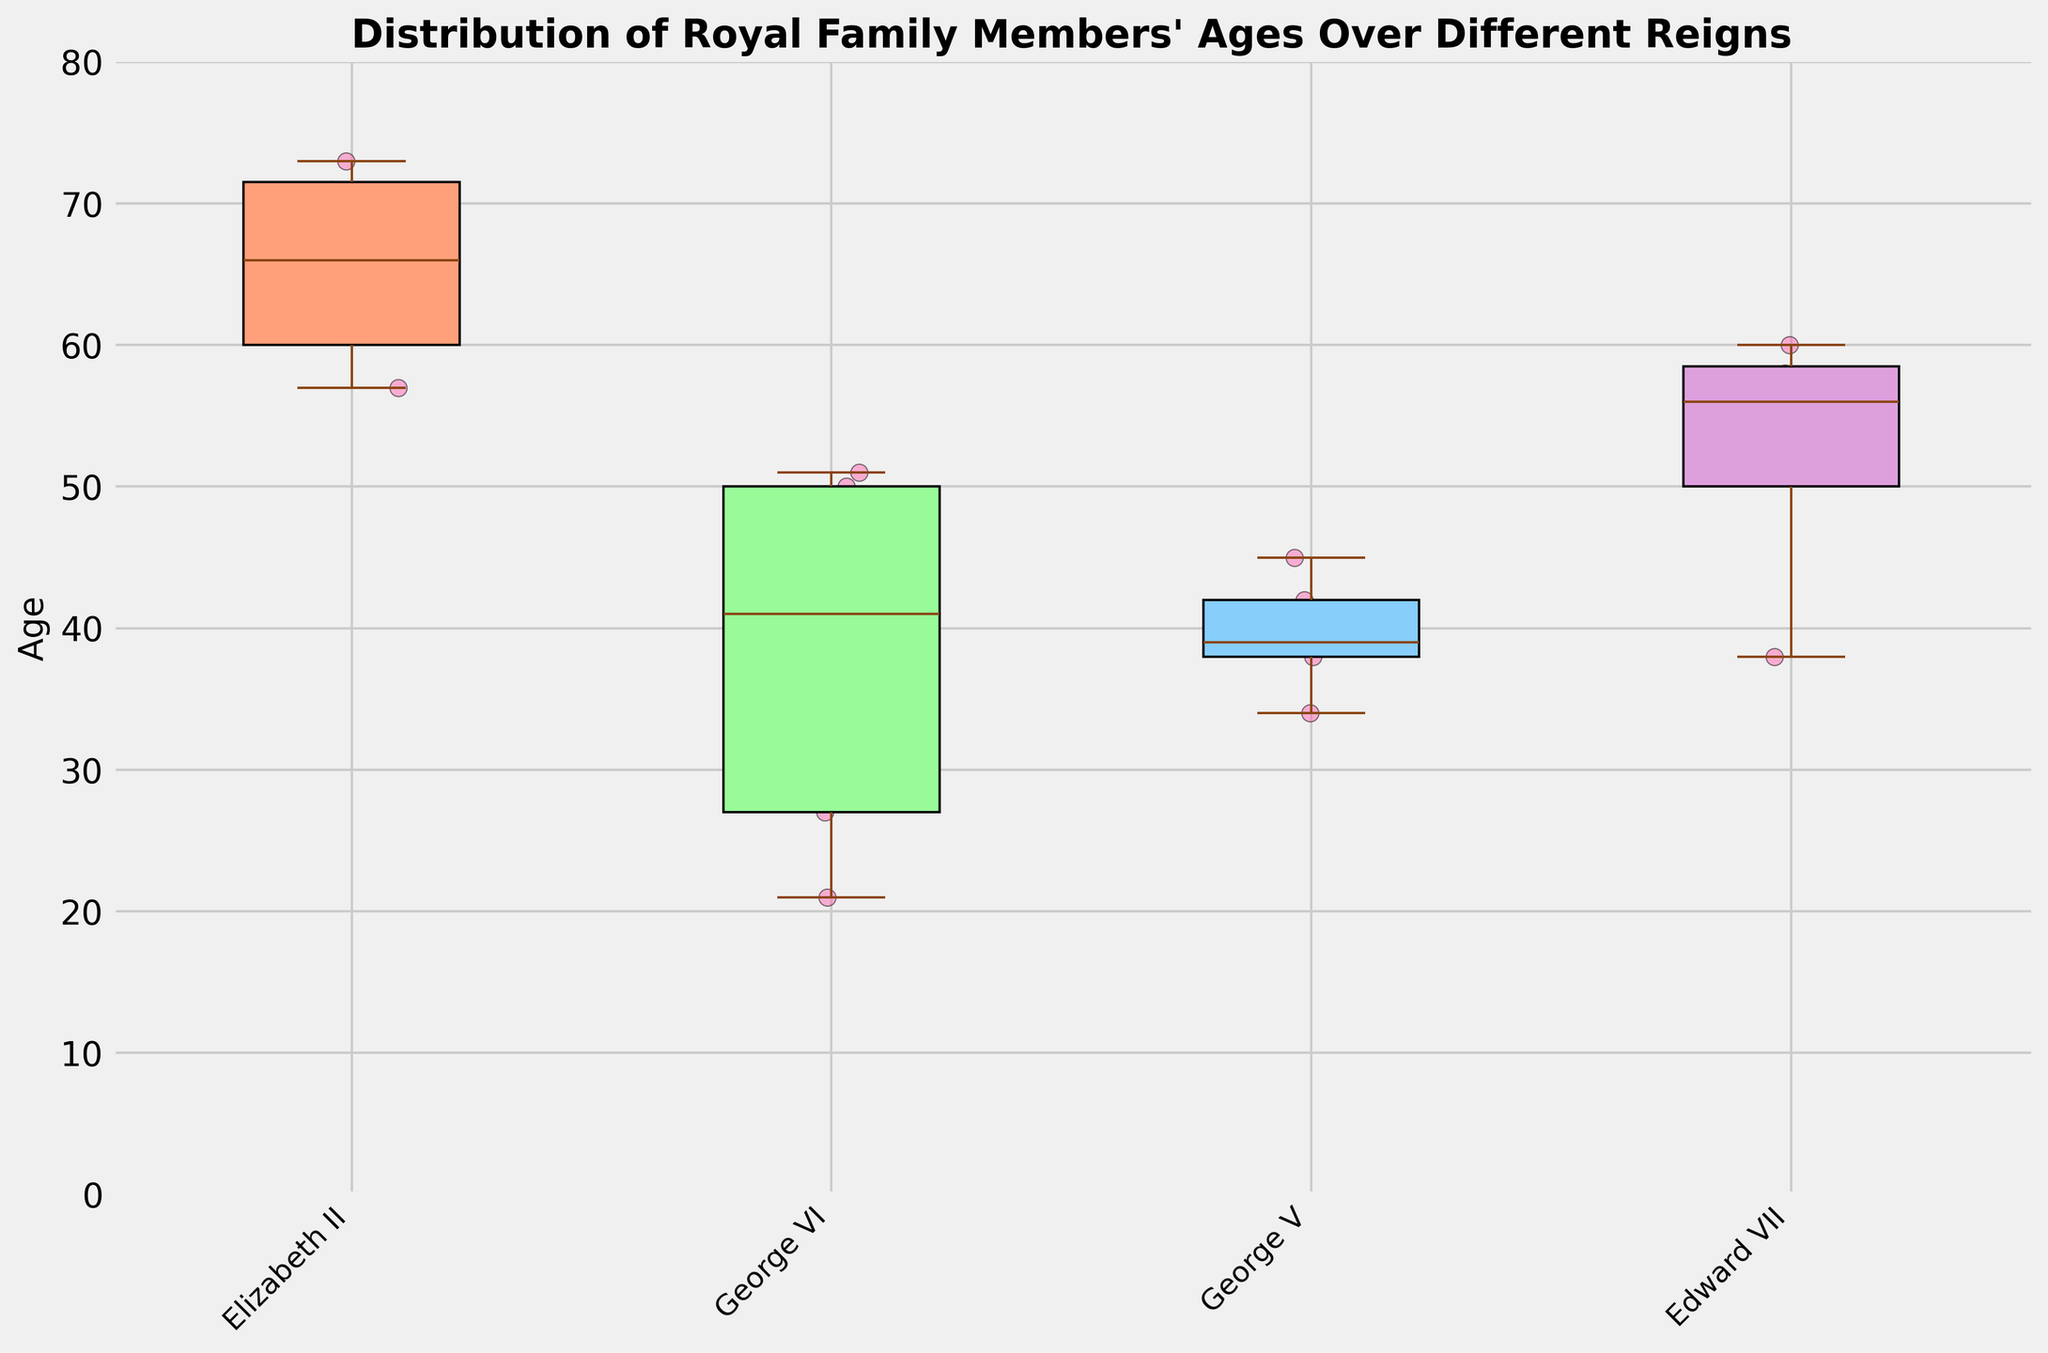What is the title of the figure? The title of the figure is displayed at the top and reads "Distribution of Royal Family Members' Ages Over Different Reigns."
Answer: Distribution of Royal Family Members' Ages Over Different Reigns Which reign has the widest age range? The widest age range is indicated by the length of the boxplot's whiskers. The reign with the longest whiskers represents the widest age range, which appears to be "Edward VII."
Answer: Edward VII How many royal family members are depicted under the reign of George V? Count the individual data points (dots) that fall under the "George V" category on the x-axis.
Answer: 5 What's the median age of members during Elizabeth II's reign? The median age is marked by the line inside the box for the "Elizabeth II" category.
Answer: 61 Which reign has the youngest member, and what is their age? The youngest member's age is identified as the lowest point on the y-axis range for each reign. The lowest point is under "George VI" with an age of 21.
Answer: George VI, 21 Compare the median ages of George V and George VI. Which reign has the higher median age? The median age is represented by the line inside each box. Compare the lines for "George V" and "George VI" categories; "George V" has a higher median age.
Answer: George V What is the interquartile range (IQR) for George VI's reign? The IQR is the length of the box representing the middle 50% of the data. The lower and upper edges of the box are the first (Q1) and third (Q3) quartiles, respectively. Estimate these values from the plot and subtract Q1 from Q3.
Answer: ~30 (estimated from visual interpretation) Which reign has the smallest number of "whiskers" longer than the box? Visually inspect the whiskers for each reign and determine which one has the shortest whiskers in comparison to its box length.
Answer: Elizabeth II How does the variation in ages during Edward VII's reign compare to that of George V's reign? Look at the length of the whiskers and the spread of the individual points (dots) for both reigns. Edward VII exhibits greater variation as suggested by longer whiskers and more spread-out data points.
Answer: Edward VII has greater variation 